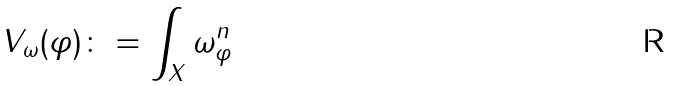Convert formula to latex. <formula><loc_0><loc_0><loc_500><loc_500>V _ { \omega } ( \varphi ) \colon = \int _ { X } \omega ^ { n } _ { \varphi }</formula> 